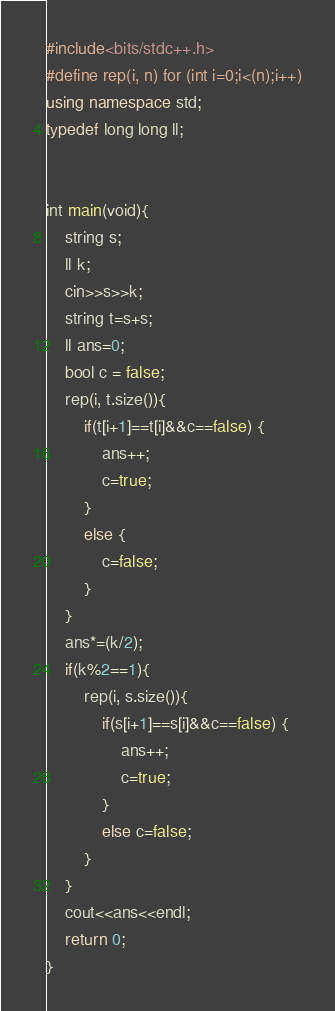Convert code to text. <code><loc_0><loc_0><loc_500><loc_500><_C++_>#include<bits/stdc++.h>
#define rep(i, n) for (int i=0;i<(n);i++)
using namespace std;
typedef long long ll;


int main(void){
    string s;
    ll k;
    cin>>s>>k;
    string t=s+s;
    ll ans=0;
    bool c = false;
    rep(i, t.size()){
        if(t[i+1]==t[i]&&c==false) {
            ans++;
            c=true;
        }
        else {
            c=false;
        }
    }
    ans*=(k/2);
    if(k%2==1){
        rep(i, s.size()){
            if(s[i+1]==s[i]&&c==false) {
                ans++;
                c=true;
            }
            else c=false;
        }
    }
    cout<<ans<<endl;
    return 0;
}</code> 